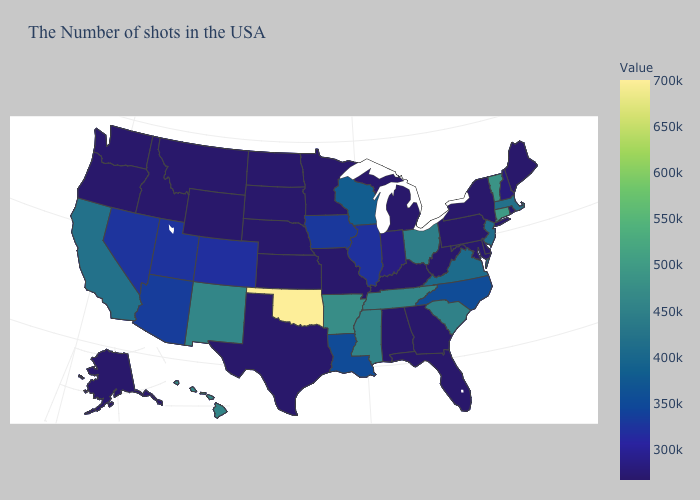Among the states that border Ohio , which have the highest value?
Give a very brief answer. Indiana. Which states have the lowest value in the Northeast?
Keep it brief. Maine, Rhode Island, New York, Pennsylvania. Does New Mexico have the lowest value in the West?
Keep it brief. No. 